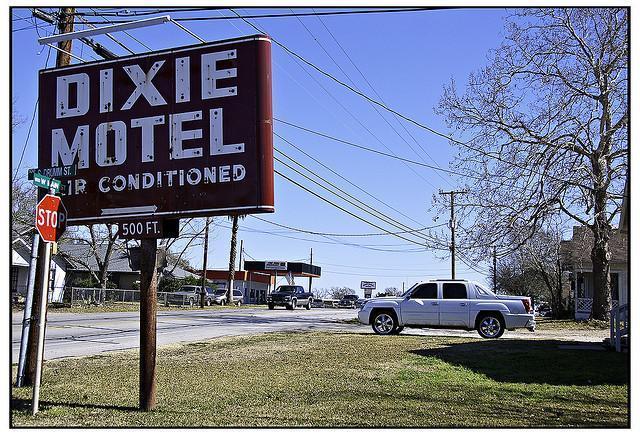How many slices of pizza are left of the fork?
Give a very brief answer. 0. 